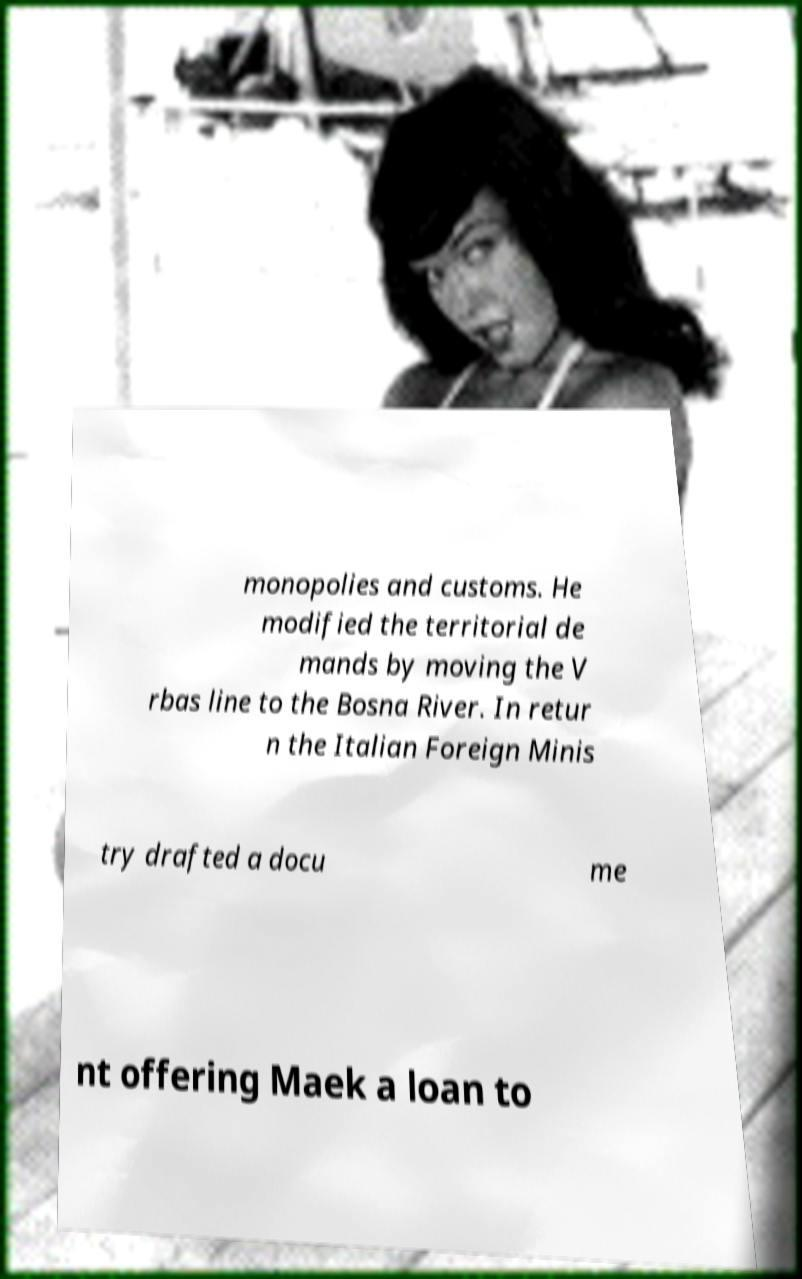Can you accurately transcribe the text from the provided image for me? monopolies and customs. He modified the territorial de mands by moving the V rbas line to the Bosna River. In retur n the Italian Foreign Minis try drafted a docu me nt offering Maek a loan to 